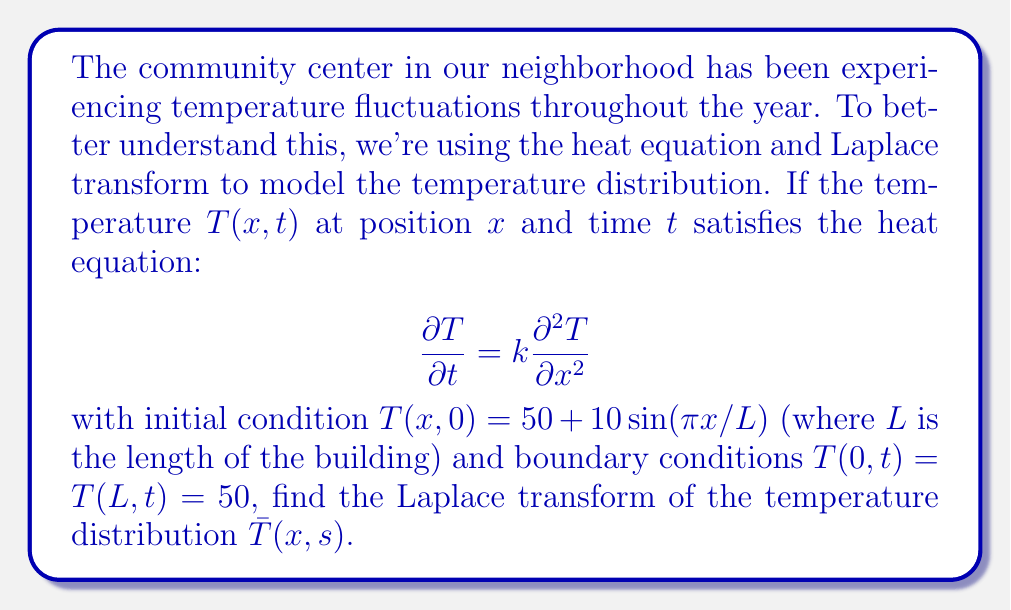Could you help me with this problem? Let's approach this step-by-step:

1) First, we take the Laplace transform of both sides of the heat equation with respect to $t$:

   $$\mathcal{L}\left\{\frac{\partial T}{\partial t}\right\} = k\mathcal{L}\left\{\frac{\partial^2 T}{\partial x^2}\right\}$$

2) Using the Laplace transform property for derivatives:

   $$s\bar{T}(x,s) - T(x,0) = k\frac{\partial^2 \bar{T}}{\partial x^2}$$

3) Substituting the initial condition:

   $$s\bar{T}(x,s) - (50 + 10\sin(\pi x/L)) = k\frac{\partial^2 \bar{T}}{\partial x^2}$$

4) Rearranging:

   $$k\frac{\partial^2 \bar{T}}{\partial x^2} - s\bar{T}(x,s) = -50 - 10\sin(\pi x/L)$$

5) This is a non-homogeneous second-order ODE. Its general solution will be of the form:

   $$\bar{T}(x,s) = C_1e^{\sqrt{s/k}x} + C_2e^{-\sqrt{s/k}x} + \frac{50}{s} + \frac{10\sin(\pi x/L)}{s+k(\pi/L)^2}$$

6) To find $C_1$ and $C_2$, we use the boundary conditions. Taking the Laplace transform of the boundary conditions:

   $$\bar{T}(0,s) = \bar{T}(L,s) = \frac{50}{s}$$

7) Applying these to our general solution:

   At $x=0$: $C_1 + C_2 = 0$
   At $x=L$: $C_1e^{\sqrt{s/k}L} + C_2e^{-\sqrt{s/k}L} = 0$

8) Solving this system of equations:

   $$C_1 = C_2 = 0$$

Therefore, the Laplace transform of the temperature distribution is:

$$\bar{T}(x,s) = \frac{50}{s} + \frac{10\sin(\pi x/L)}{s+k(\pi/L)^2}$$
Answer: $$\bar{T}(x,s) = \frac{50}{s} + \frac{10\sin(\pi x/L)}{s+k(\pi/L)^2}$$ 